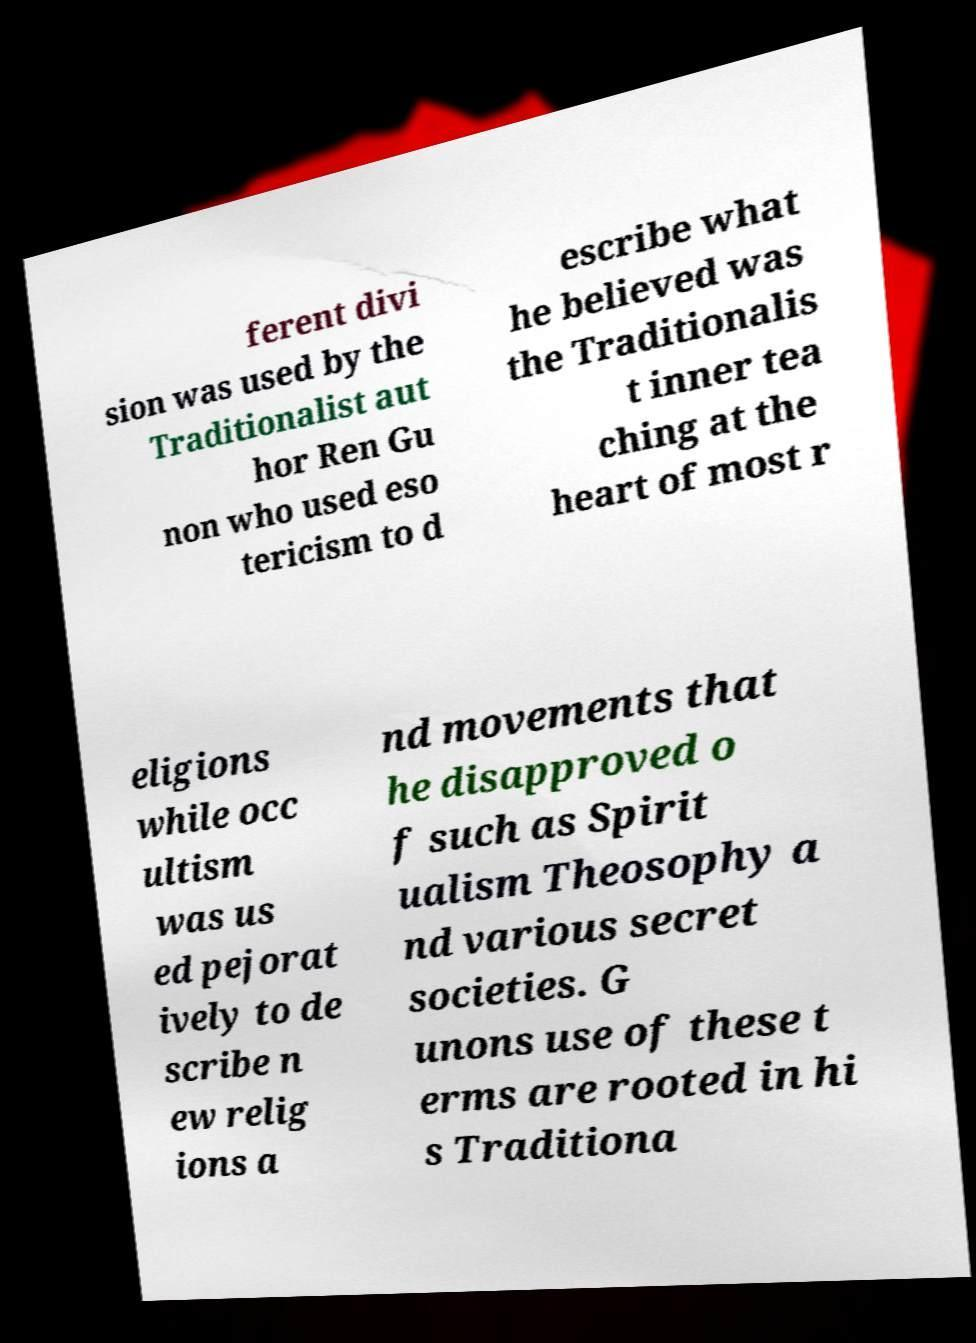Could you assist in decoding the text presented in this image and type it out clearly? ferent divi sion was used by the Traditionalist aut hor Ren Gu non who used eso tericism to d escribe what he believed was the Traditionalis t inner tea ching at the heart of most r eligions while occ ultism was us ed pejorat ively to de scribe n ew relig ions a nd movements that he disapproved o f such as Spirit ualism Theosophy a nd various secret societies. G unons use of these t erms are rooted in hi s Traditiona 